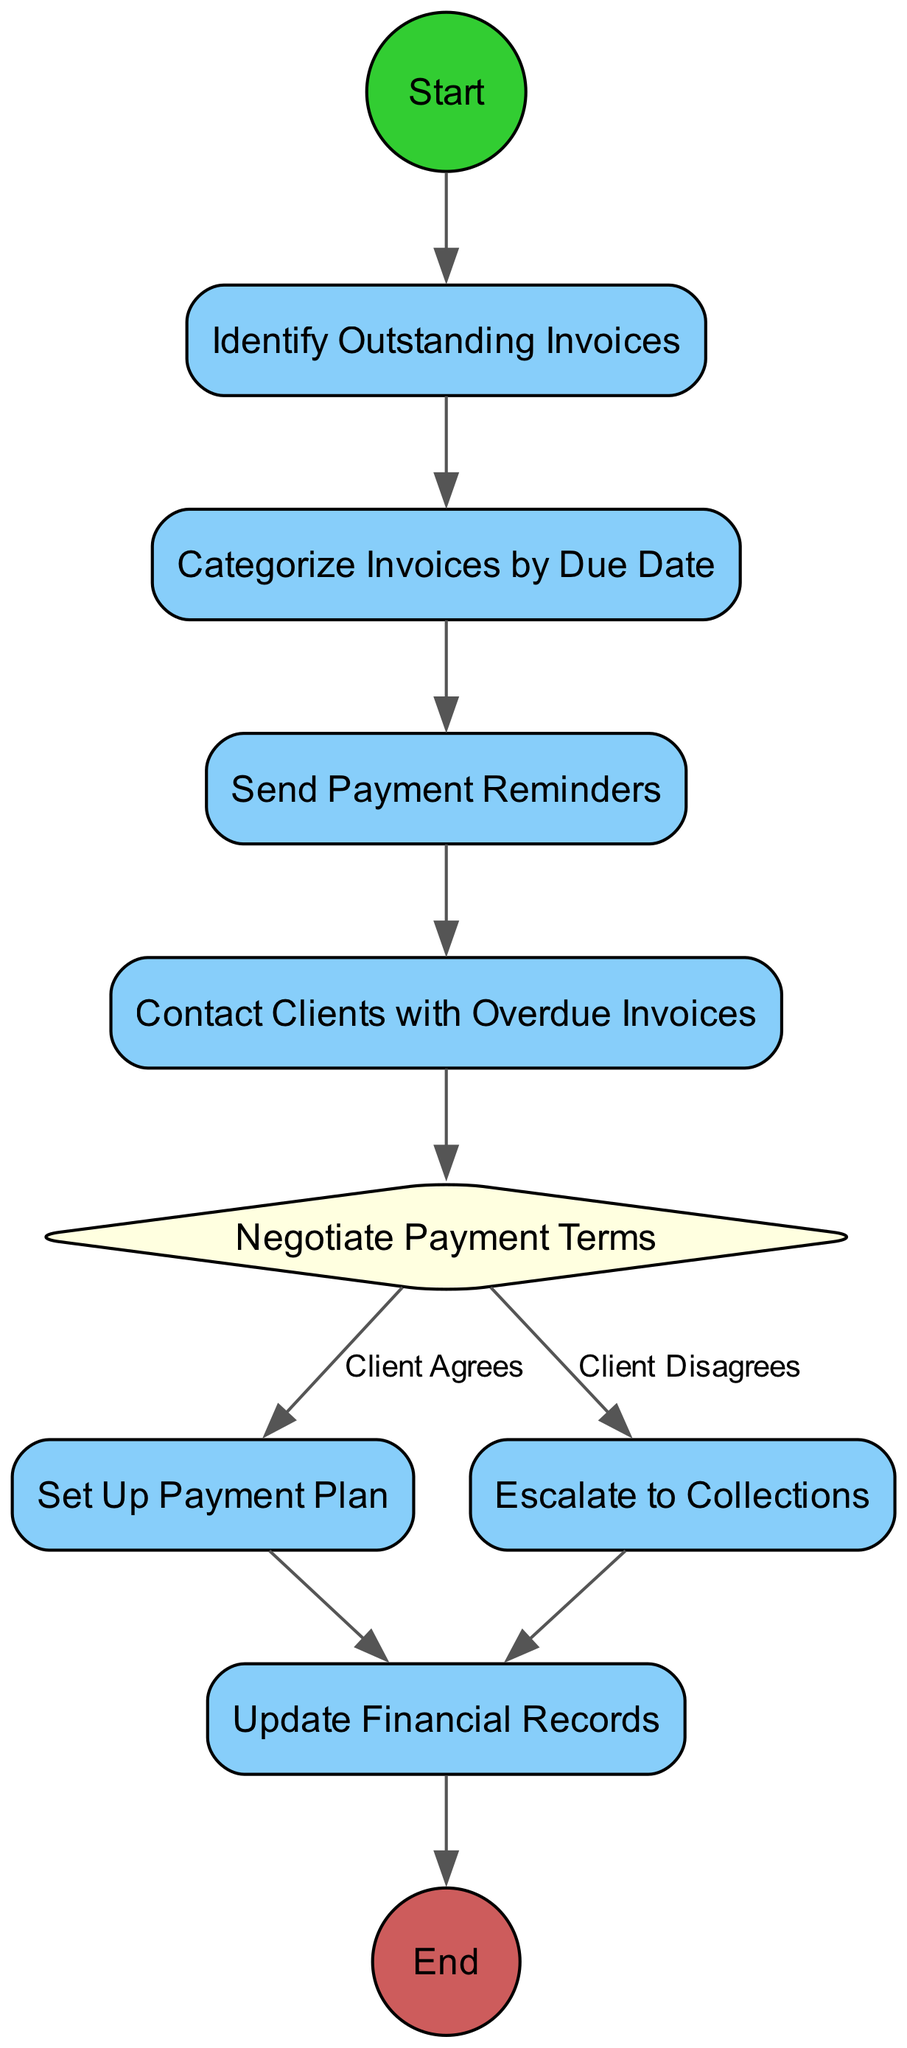What is the first activity in the diagram? The diagram starts with the activity labeled "Identify Outstanding Invoices", which is the initial action in the flow of managing outstanding invoices and payments.
Answer: Identify Outstanding Invoices How many decision nodes are present in the diagram? There is one decision node in the diagram, which is "Negotiate Payment Terms". This decision leads to two branches based on the client's agreement or disagreement.
Answer: 1 What happens after "Contact Clients with Overdue Invoices"? The next step after "Contact Clients with Overdue Invoices" is "Negotiate Payment Terms", which indicates that contacting clients is followed by an attempt to discuss and set payment terms.
Answer: Negotiate Payment Terms What condition leads to "Set Up Payment Plan"? The condition that leads to "Set Up Payment Plan" is when the "Client Agrees" during the "Negotiate Payment Terms" step. This decision allows for a payment plan to be established.
Answer: Client Agrees What is the last activity in the workflow? The last activity in the workflow is "Update Financial Records", which signifies the completion of the process after all previous actions have been taken.
Answer: Update Financial Records If a client disagrees during negotiation, what is the next action taken? If a client disagrees during negotiation, the next action taken is "Escalate to Collections", which indicates a move towards more serious steps for recovering the outstanding invoices.
Answer: Escalate to Collections How many activities occur before contacting clients? Three activities occur before contacting clients: "Identify Outstanding Invoices", "Categorize Invoices by Due Date", and "Send Payment Reminders", indicating a sequential approach to managing invoices before direct client contact.
Answer: 3 What type of node is "Negotiate Payment Terms"? "Negotiate Payment Terms" is a decision node, as it contains conditions that branch the workflow based on the client's response, either leading to a payment plan or collections.
Answer: Decision node 